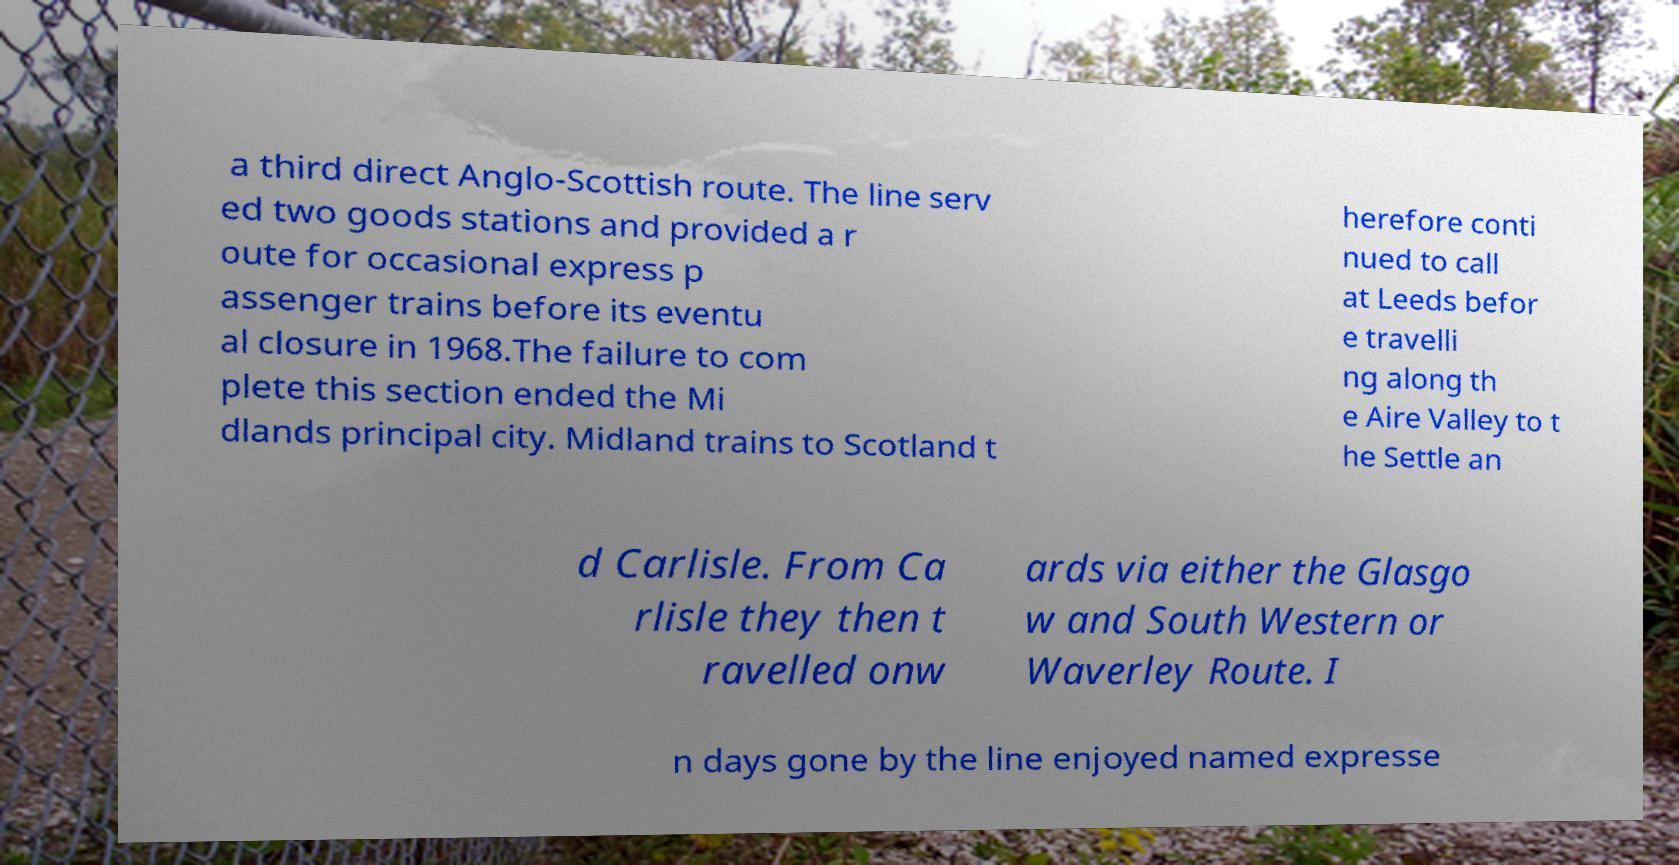Can you accurately transcribe the text from the provided image for me? a third direct Anglo-Scottish route. The line serv ed two goods stations and provided a r oute for occasional express p assenger trains before its eventu al closure in 1968.The failure to com plete this section ended the Mi dlands principal city. Midland trains to Scotland t herefore conti nued to call at Leeds befor e travelli ng along th e Aire Valley to t he Settle an d Carlisle. From Ca rlisle they then t ravelled onw ards via either the Glasgo w and South Western or Waverley Route. I n days gone by the line enjoyed named expresse 